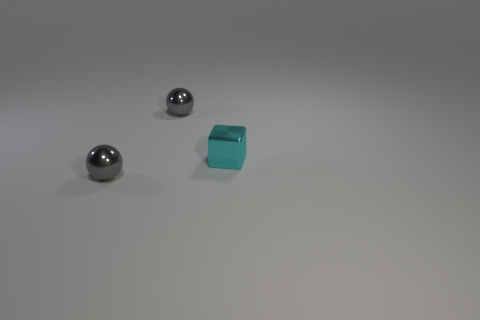What number of other things are the same size as the metal block? 2 